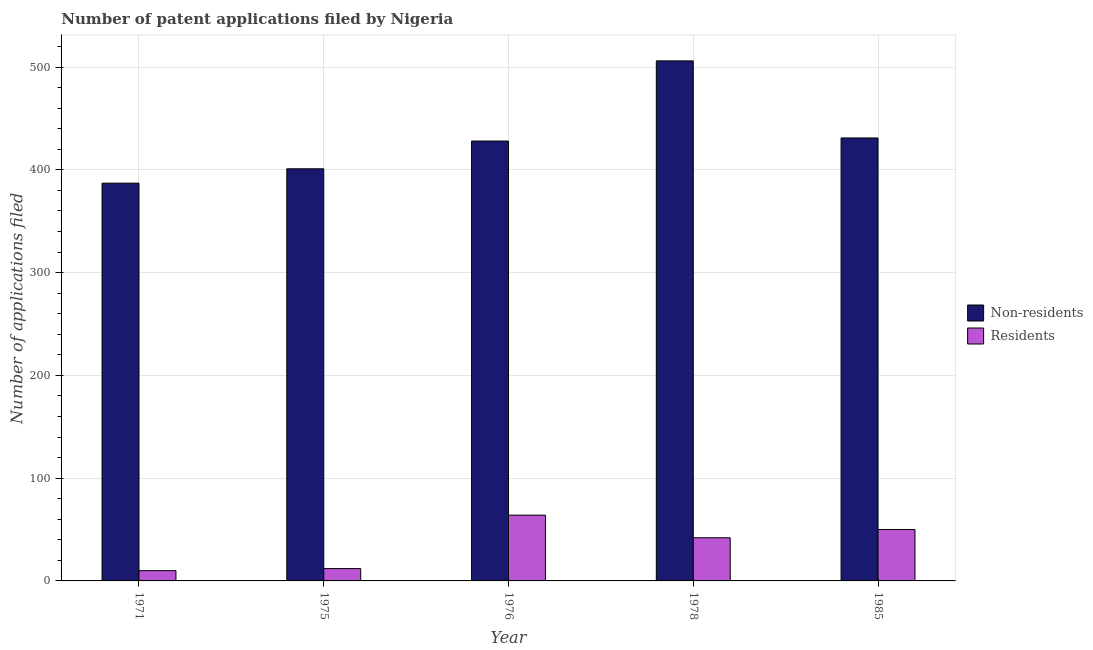How many different coloured bars are there?
Provide a succinct answer. 2. How many bars are there on the 4th tick from the left?
Your response must be concise. 2. What is the number of patent applications by non residents in 1985?
Provide a succinct answer. 431. Across all years, what is the maximum number of patent applications by non residents?
Provide a short and direct response. 506. Across all years, what is the minimum number of patent applications by non residents?
Keep it short and to the point. 387. In which year was the number of patent applications by non residents maximum?
Your response must be concise. 1978. In which year was the number of patent applications by non residents minimum?
Ensure brevity in your answer.  1971. What is the total number of patent applications by non residents in the graph?
Your response must be concise. 2153. What is the difference between the number of patent applications by non residents in 1971 and that in 1975?
Offer a very short reply. -14. What is the difference between the number of patent applications by residents in 1985 and the number of patent applications by non residents in 1975?
Your response must be concise. 38. What is the average number of patent applications by non residents per year?
Make the answer very short. 430.6. In the year 1976, what is the difference between the number of patent applications by residents and number of patent applications by non residents?
Make the answer very short. 0. What is the ratio of the number of patent applications by residents in 1971 to that in 1976?
Your response must be concise. 0.16. Is the difference between the number of patent applications by non residents in 1975 and 1976 greater than the difference between the number of patent applications by residents in 1975 and 1976?
Offer a very short reply. No. What is the difference between the highest and the lowest number of patent applications by residents?
Offer a terse response. 54. In how many years, is the number of patent applications by non residents greater than the average number of patent applications by non residents taken over all years?
Your answer should be compact. 2. What does the 2nd bar from the left in 1985 represents?
Give a very brief answer. Residents. What does the 2nd bar from the right in 1971 represents?
Your answer should be very brief. Non-residents. Are all the bars in the graph horizontal?
Make the answer very short. No. Are the values on the major ticks of Y-axis written in scientific E-notation?
Provide a short and direct response. No. Does the graph contain any zero values?
Give a very brief answer. No. Where does the legend appear in the graph?
Your answer should be compact. Center right. How many legend labels are there?
Your answer should be very brief. 2. What is the title of the graph?
Provide a succinct answer. Number of patent applications filed by Nigeria. Does "Private consumption" appear as one of the legend labels in the graph?
Give a very brief answer. No. What is the label or title of the X-axis?
Provide a short and direct response. Year. What is the label or title of the Y-axis?
Your answer should be very brief. Number of applications filed. What is the Number of applications filed in Non-residents in 1971?
Offer a very short reply. 387. What is the Number of applications filed of Non-residents in 1975?
Offer a terse response. 401. What is the Number of applications filed in Residents in 1975?
Your answer should be very brief. 12. What is the Number of applications filed of Non-residents in 1976?
Provide a short and direct response. 428. What is the Number of applications filed in Residents in 1976?
Your answer should be very brief. 64. What is the Number of applications filed of Non-residents in 1978?
Offer a terse response. 506. What is the Number of applications filed in Residents in 1978?
Offer a terse response. 42. What is the Number of applications filed in Non-residents in 1985?
Your answer should be compact. 431. Across all years, what is the maximum Number of applications filed of Non-residents?
Keep it short and to the point. 506. Across all years, what is the minimum Number of applications filed in Non-residents?
Offer a terse response. 387. Across all years, what is the minimum Number of applications filed of Residents?
Keep it short and to the point. 10. What is the total Number of applications filed of Non-residents in the graph?
Make the answer very short. 2153. What is the total Number of applications filed of Residents in the graph?
Offer a very short reply. 178. What is the difference between the Number of applications filed in Non-residents in 1971 and that in 1976?
Provide a succinct answer. -41. What is the difference between the Number of applications filed in Residents in 1971 and that in 1976?
Your response must be concise. -54. What is the difference between the Number of applications filed in Non-residents in 1971 and that in 1978?
Ensure brevity in your answer.  -119. What is the difference between the Number of applications filed in Residents in 1971 and that in 1978?
Ensure brevity in your answer.  -32. What is the difference between the Number of applications filed in Non-residents in 1971 and that in 1985?
Your answer should be compact. -44. What is the difference between the Number of applications filed of Residents in 1975 and that in 1976?
Offer a very short reply. -52. What is the difference between the Number of applications filed in Non-residents in 1975 and that in 1978?
Offer a terse response. -105. What is the difference between the Number of applications filed in Residents in 1975 and that in 1978?
Offer a very short reply. -30. What is the difference between the Number of applications filed of Non-residents in 1975 and that in 1985?
Make the answer very short. -30. What is the difference between the Number of applications filed of Residents in 1975 and that in 1985?
Your answer should be very brief. -38. What is the difference between the Number of applications filed in Non-residents in 1976 and that in 1978?
Make the answer very short. -78. What is the difference between the Number of applications filed of Non-residents in 1976 and that in 1985?
Provide a succinct answer. -3. What is the difference between the Number of applications filed of Residents in 1976 and that in 1985?
Your response must be concise. 14. What is the difference between the Number of applications filed in Non-residents in 1971 and the Number of applications filed in Residents in 1975?
Make the answer very short. 375. What is the difference between the Number of applications filed in Non-residents in 1971 and the Number of applications filed in Residents in 1976?
Offer a terse response. 323. What is the difference between the Number of applications filed in Non-residents in 1971 and the Number of applications filed in Residents in 1978?
Offer a very short reply. 345. What is the difference between the Number of applications filed in Non-residents in 1971 and the Number of applications filed in Residents in 1985?
Make the answer very short. 337. What is the difference between the Number of applications filed in Non-residents in 1975 and the Number of applications filed in Residents in 1976?
Make the answer very short. 337. What is the difference between the Number of applications filed in Non-residents in 1975 and the Number of applications filed in Residents in 1978?
Keep it short and to the point. 359. What is the difference between the Number of applications filed of Non-residents in 1975 and the Number of applications filed of Residents in 1985?
Your answer should be very brief. 351. What is the difference between the Number of applications filed of Non-residents in 1976 and the Number of applications filed of Residents in 1978?
Make the answer very short. 386. What is the difference between the Number of applications filed in Non-residents in 1976 and the Number of applications filed in Residents in 1985?
Your response must be concise. 378. What is the difference between the Number of applications filed in Non-residents in 1978 and the Number of applications filed in Residents in 1985?
Provide a short and direct response. 456. What is the average Number of applications filed of Non-residents per year?
Provide a short and direct response. 430.6. What is the average Number of applications filed of Residents per year?
Offer a very short reply. 35.6. In the year 1971, what is the difference between the Number of applications filed of Non-residents and Number of applications filed of Residents?
Keep it short and to the point. 377. In the year 1975, what is the difference between the Number of applications filed in Non-residents and Number of applications filed in Residents?
Your answer should be compact. 389. In the year 1976, what is the difference between the Number of applications filed of Non-residents and Number of applications filed of Residents?
Provide a succinct answer. 364. In the year 1978, what is the difference between the Number of applications filed in Non-residents and Number of applications filed in Residents?
Make the answer very short. 464. In the year 1985, what is the difference between the Number of applications filed in Non-residents and Number of applications filed in Residents?
Keep it short and to the point. 381. What is the ratio of the Number of applications filed in Non-residents in 1971 to that in 1975?
Your answer should be very brief. 0.97. What is the ratio of the Number of applications filed of Residents in 1971 to that in 1975?
Your answer should be compact. 0.83. What is the ratio of the Number of applications filed of Non-residents in 1971 to that in 1976?
Ensure brevity in your answer.  0.9. What is the ratio of the Number of applications filed in Residents in 1971 to that in 1976?
Your answer should be very brief. 0.16. What is the ratio of the Number of applications filed in Non-residents in 1971 to that in 1978?
Your answer should be very brief. 0.76. What is the ratio of the Number of applications filed of Residents in 1971 to that in 1978?
Give a very brief answer. 0.24. What is the ratio of the Number of applications filed of Non-residents in 1971 to that in 1985?
Ensure brevity in your answer.  0.9. What is the ratio of the Number of applications filed of Non-residents in 1975 to that in 1976?
Offer a terse response. 0.94. What is the ratio of the Number of applications filed in Residents in 1975 to that in 1976?
Your answer should be very brief. 0.19. What is the ratio of the Number of applications filed of Non-residents in 1975 to that in 1978?
Provide a short and direct response. 0.79. What is the ratio of the Number of applications filed in Residents in 1975 to that in 1978?
Offer a terse response. 0.29. What is the ratio of the Number of applications filed in Non-residents in 1975 to that in 1985?
Provide a short and direct response. 0.93. What is the ratio of the Number of applications filed in Residents in 1975 to that in 1985?
Provide a short and direct response. 0.24. What is the ratio of the Number of applications filed of Non-residents in 1976 to that in 1978?
Give a very brief answer. 0.85. What is the ratio of the Number of applications filed in Residents in 1976 to that in 1978?
Offer a very short reply. 1.52. What is the ratio of the Number of applications filed in Non-residents in 1976 to that in 1985?
Provide a succinct answer. 0.99. What is the ratio of the Number of applications filed in Residents in 1976 to that in 1985?
Your answer should be very brief. 1.28. What is the ratio of the Number of applications filed in Non-residents in 1978 to that in 1985?
Ensure brevity in your answer.  1.17. What is the ratio of the Number of applications filed in Residents in 1978 to that in 1985?
Provide a succinct answer. 0.84. What is the difference between the highest and the second highest Number of applications filed in Non-residents?
Ensure brevity in your answer.  75. What is the difference between the highest and the second highest Number of applications filed of Residents?
Provide a succinct answer. 14. What is the difference between the highest and the lowest Number of applications filed of Non-residents?
Make the answer very short. 119. 